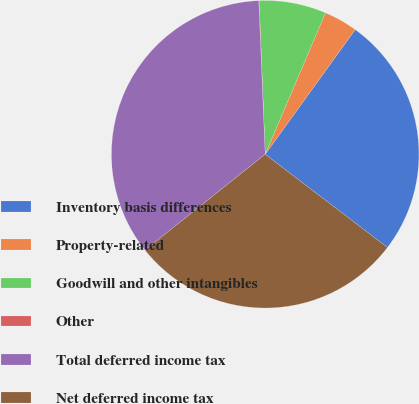Convert chart. <chart><loc_0><loc_0><loc_500><loc_500><pie_chart><fcel>Inventory basis differences<fcel>Property-related<fcel>Goodwill and other intangibles<fcel>Other<fcel>Total deferred income tax<fcel>Net deferred income tax<nl><fcel>25.42%<fcel>3.54%<fcel>7.04%<fcel>0.04%<fcel>35.05%<fcel>28.92%<nl></chart> 